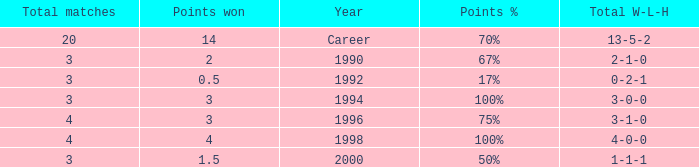Can you tell me the lowest Total natches that has the Points won of 3, and the Year of 1994? 3.0. 